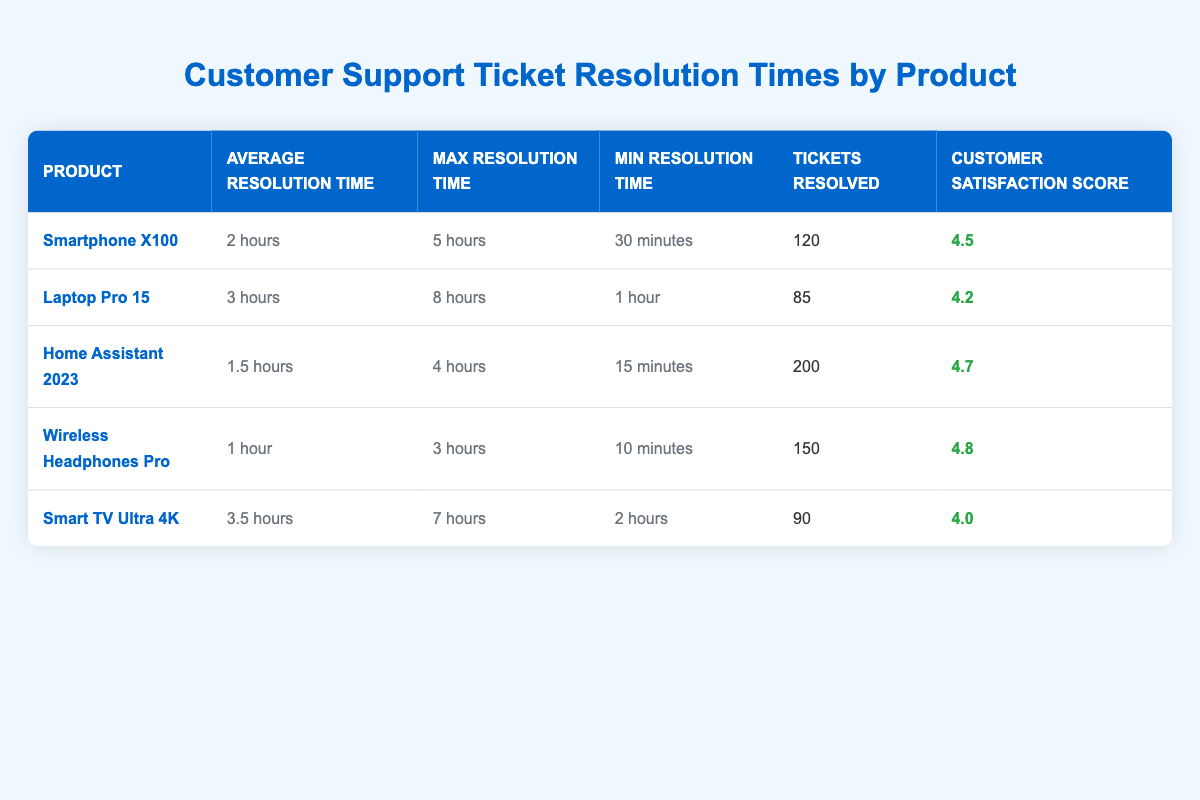What is the average resolution time for the Wireless Headphones Pro? According to the table, the average resolution time listed for Wireless Headphones Pro is "1 hour."
Answer: 1 hour Which product has the highest customer satisfaction score? Looking at the customer satisfaction scores, the Wireless Headphones Pro has the highest score at 4.8.
Answer: Wireless Headphones Pro What is the max resolution time for the Home Assistant 2023? The table indicates that the maximum resolution time for Home Assistant 2023 is "4 hours."
Answer: 4 hours How many tickets were resolved for the Laptop Pro 15? The table shows that 85 tickets were resolved for the Laptop Pro 15.
Answer: 85 What is the difference in average resolution time between the Smartphone X100 and the Smart TV Ultra 4K? The average resolution time for Smartphone X100 is 2 hours and for Smart TV Ultra 4K it is 3.5 hours. The difference is 3.5 hours - 2 hours = 1.5 hours.
Answer: 1.5 hours Is the minimum resolution time for the Wireless Headphones Pro less than 15 minutes? The minimum resolution time for Wireless Headphones Pro is 10 minutes, which is indeed less than 15 minutes.
Answer: Yes Which product has resolved more tickets, the Laptop Pro 15 or the Smart TV Ultra 4K? The Laptop Pro 15 resolved 85 tickets, while the Smart TV Ultra 4K resolved 90 tickets. Therefore, Smart TV Ultra 4K has resolved more tickets.
Answer: Smart TV Ultra 4K If you combine the tickets resolved for Home Assistant 2023 and Wireless Headphones Pro, what is their total? Home Assistant 2023 resolved 200 tickets and Wireless Headphones Pro resolved 150 tickets. The total is 200 + 150 = 350 tickets.
Answer: 350 What is the average resolution time for all products listed in the table? To calculate the average resolution time, we take the average of the individual average resolution times: (2 + 3 + 1.5 + 1 + 3.5) hours / 5 = 2 hours.
Answer: 2 hours Is the customer satisfaction score for the Smart TV Ultra 4K above 4.5? The customer satisfaction score for Smart TV Ultra 4K is 4.0, which is not above 4.5.
Answer: No 